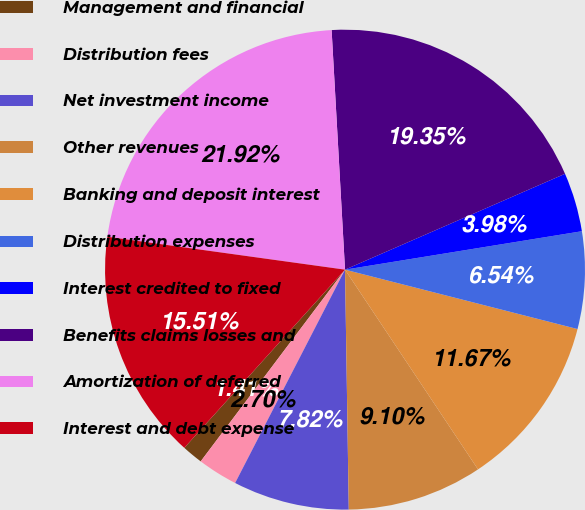Convert chart. <chart><loc_0><loc_0><loc_500><loc_500><pie_chart><fcel>Management and financial<fcel>Distribution fees<fcel>Net investment income<fcel>Other revenues<fcel>Banking and deposit interest<fcel>Distribution expenses<fcel>Interest credited to fixed<fcel>Benefits claims losses and<fcel>Amortization of deferred<fcel>Interest and debt expense<nl><fcel>1.41%<fcel>2.7%<fcel>7.82%<fcel>9.1%<fcel>11.67%<fcel>6.54%<fcel>3.98%<fcel>19.35%<fcel>21.92%<fcel>15.51%<nl></chart> 